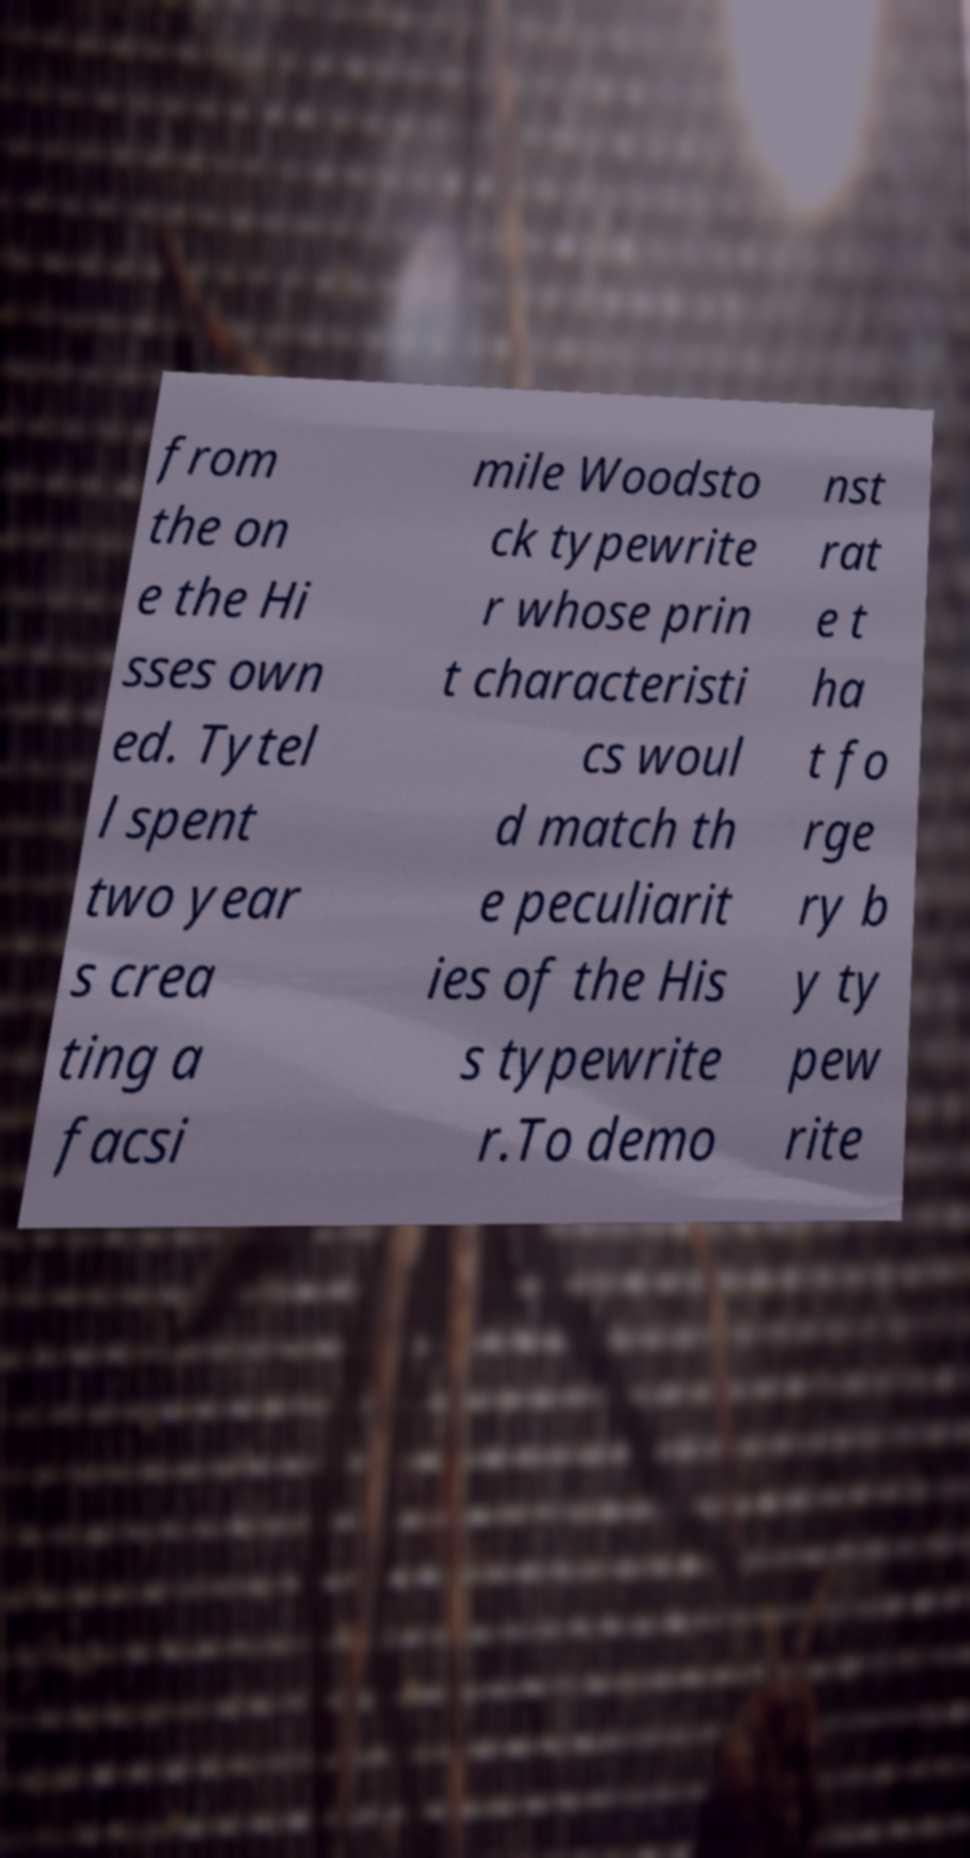Could you extract and type out the text from this image? from the on e the Hi sses own ed. Tytel l spent two year s crea ting a facsi mile Woodsto ck typewrite r whose prin t characteristi cs woul d match th e peculiarit ies of the His s typewrite r.To demo nst rat e t ha t fo rge ry b y ty pew rite 